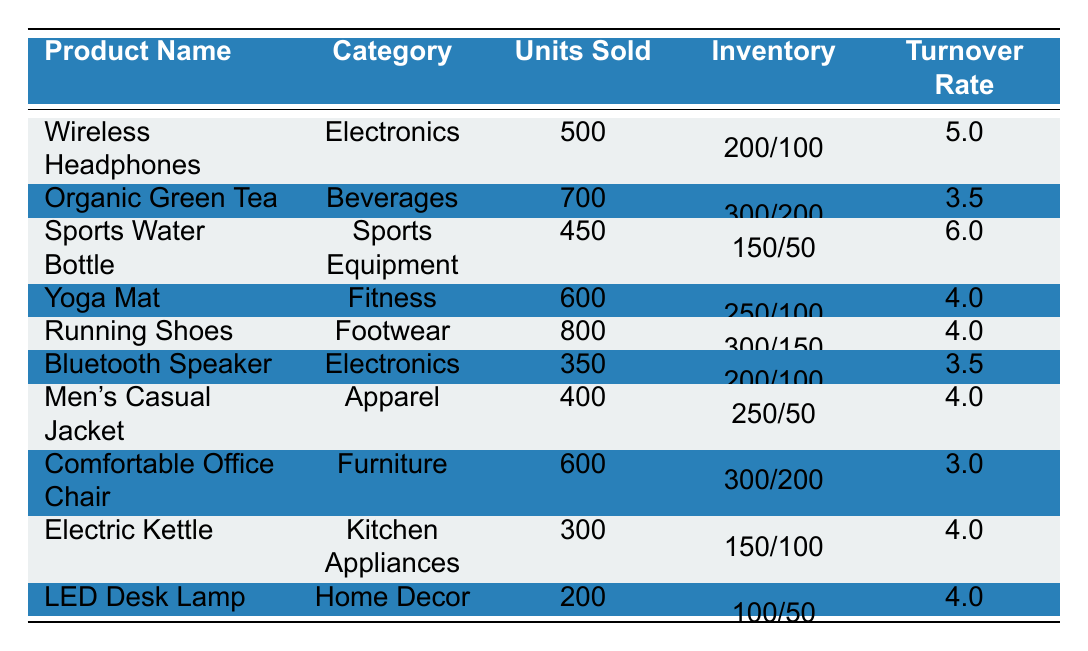What is the turnover rate for Running Shoes? The turnover rate for Running Shoes is listed in the table under the "Turnover Rate" column next to the product name. It shows a value of 4.0.
Answer: 4.0 Which product has the highest inventory turnover rate? The highest turnover rate is 6.0, shown for Sports Water Bottle in the corresponding row of the table.
Answer: Sports Water Bottle How many units of Wireless Headphones were sold? The number of units sold for Wireless Headphones is directly listed in the "Units Sold" column. It states 500 units.
Answer: 500 What is the average turnover rate for the Electronics category? To find the average, sum the turnover rates for all Electronics products: (5.0 + 3.5) / 2 = 4.25, as there are 2 Electronics products.
Answer: 4.25 Is the turnover rate for Comfortable Office Chair higher than 4.0? The turnover rate for Comfortable Office Chair is stated as 3.0 in the table, which is lower than 4.0.
Answer: No Which category has the most units sold? To determine this, look at the "Units Sold" column and find the maximum value: Running Shoes has the highest units sold at 800.
Answer: Footwear What is the total number of units sold for products in the Beverages category? The only product in the Beverages category is Organic Green Tea, which has 700 units sold. Thus, the total is 700.
Answer: 700 How much more inventory was available at the beginning for Yoga Mats than at the end? The beginning inventory for Yoga Mats is 250 and the ending inventory is 100. Subtracting these gives 250 - 100 = 150 more units available at the beginning.
Answer: 150 Which product in the Apparel category has the lowest turnover rate? In the Apparel category, the only product listed is Men's Casual Jacket with a turnover rate of 4.0, so it is also the lowest by default.
Answer: Men's Casual Jacket If the ending inventory for the Sports Water Bottle was 100 more, what would its turnover rate be? The ending inventory for Sports Water Bottle is 50. If it were 100 more, it would be 150. To recalculate the turnover rate, we would need to find units sold (450) and the average inventory of (150 + 250)/2 = 200. Thus, the new rate is 450/200 = 2.25.
Answer: 2.25 